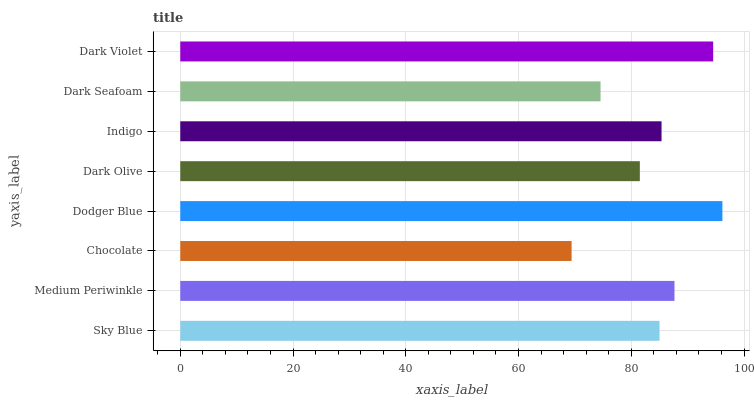Is Chocolate the minimum?
Answer yes or no. Yes. Is Dodger Blue the maximum?
Answer yes or no. Yes. Is Medium Periwinkle the minimum?
Answer yes or no. No. Is Medium Periwinkle the maximum?
Answer yes or no. No. Is Medium Periwinkle greater than Sky Blue?
Answer yes or no. Yes. Is Sky Blue less than Medium Periwinkle?
Answer yes or no. Yes. Is Sky Blue greater than Medium Periwinkle?
Answer yes or no. No. Is Medium Periwinkle less than Sky Blue?
Answer yes or no. No. Is Indigo the high median?
Answer yes or no. Yes. Is Sky Blue the low median?
Answer yes or no. Yes. Is Dark Seafoam the high median?
Answer yes or no. No. Is Dark Violet the low median?
Answer yes or no. No. 